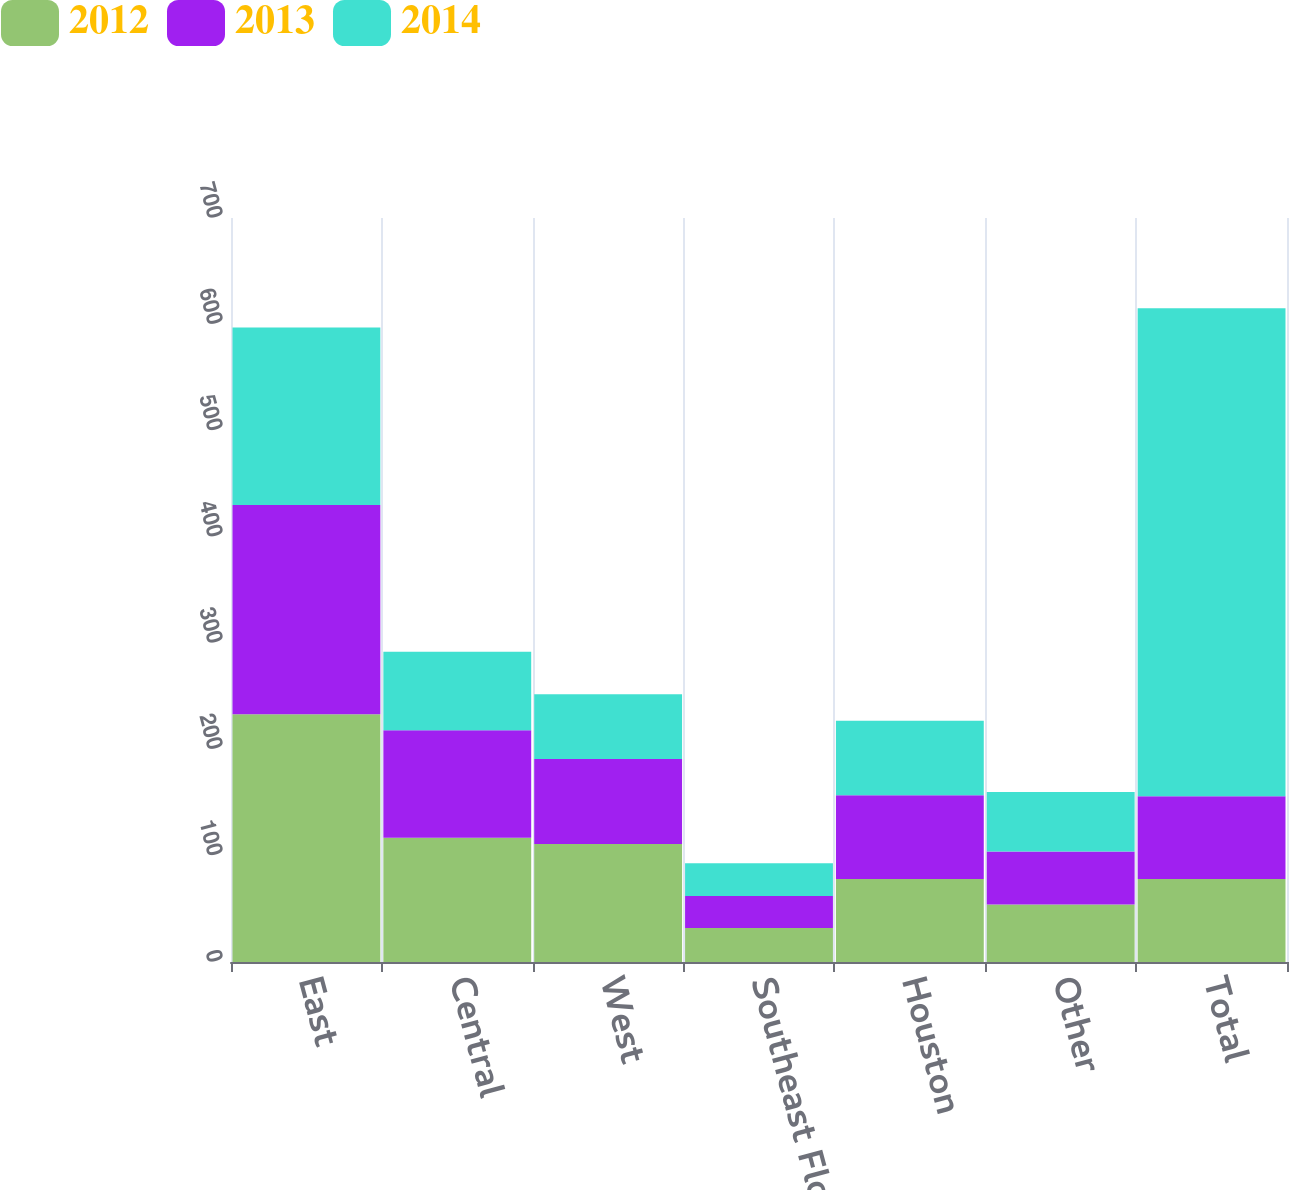Convert chart to OTSL. <chart><loc_0><loc_0><loc_500><loc_500><stacked_bar_chart><ecel><fcel>East<fcel>Central<fcel>West<fcel>Southeast Florida<fcel>Houston<fcel>Other<fcel>Total<nl><fcel>2012<fcel>233<fcel>117<fcel>111<fcel>32<fcel>78<fcel>54<fcel>78<nl><fcel>2013<fcel>197<fcel>101<fcel>80<fcel>30<fcel>79<fcel>50<fcel>78<nl><fcel>2014<fcel>167<fcel>74<fcel>61<fcel>31<fcel>70<fcel>56<fcel>459<nl></chart> 